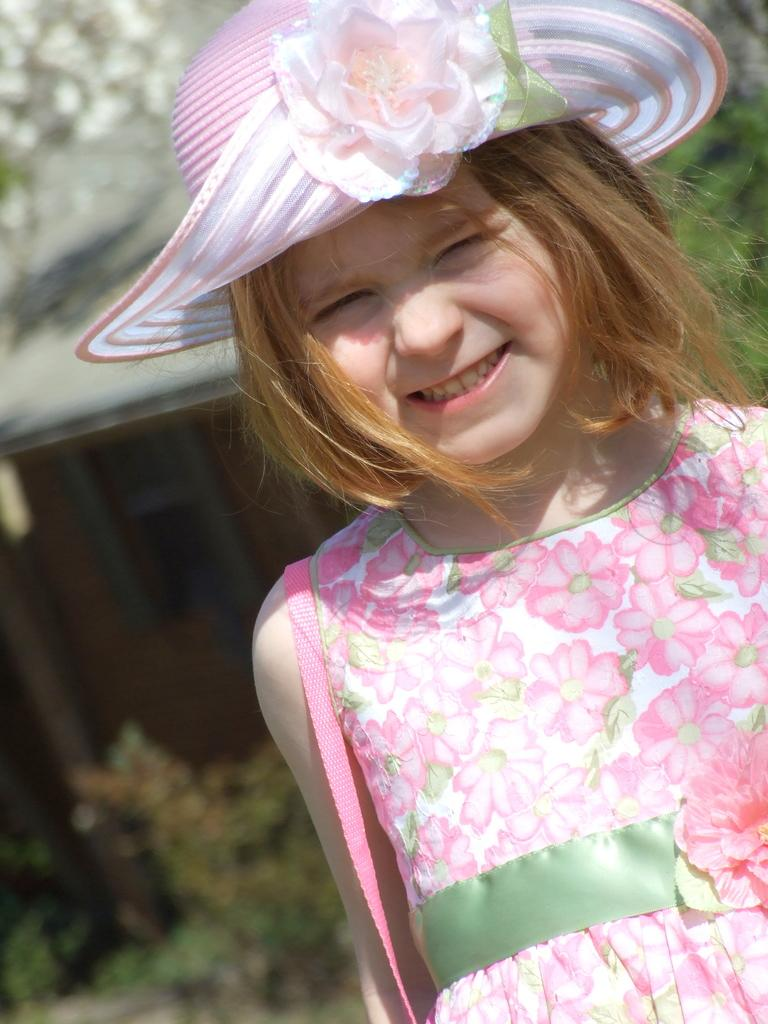Who is the main subject in the image? There is a girl in the image. What is the girl doing in the image? The girl is standing. What is the girl wearing on her head? The girl is wearing a hat. What type of structure can be seen in the image? There is a house with a roof in the image. What type of vegetation is present in the image? There are plants and a tree in the image. What type of stone can be seen in the girl's hand in the image? There is no stone present in the girl's hand or in the image. 